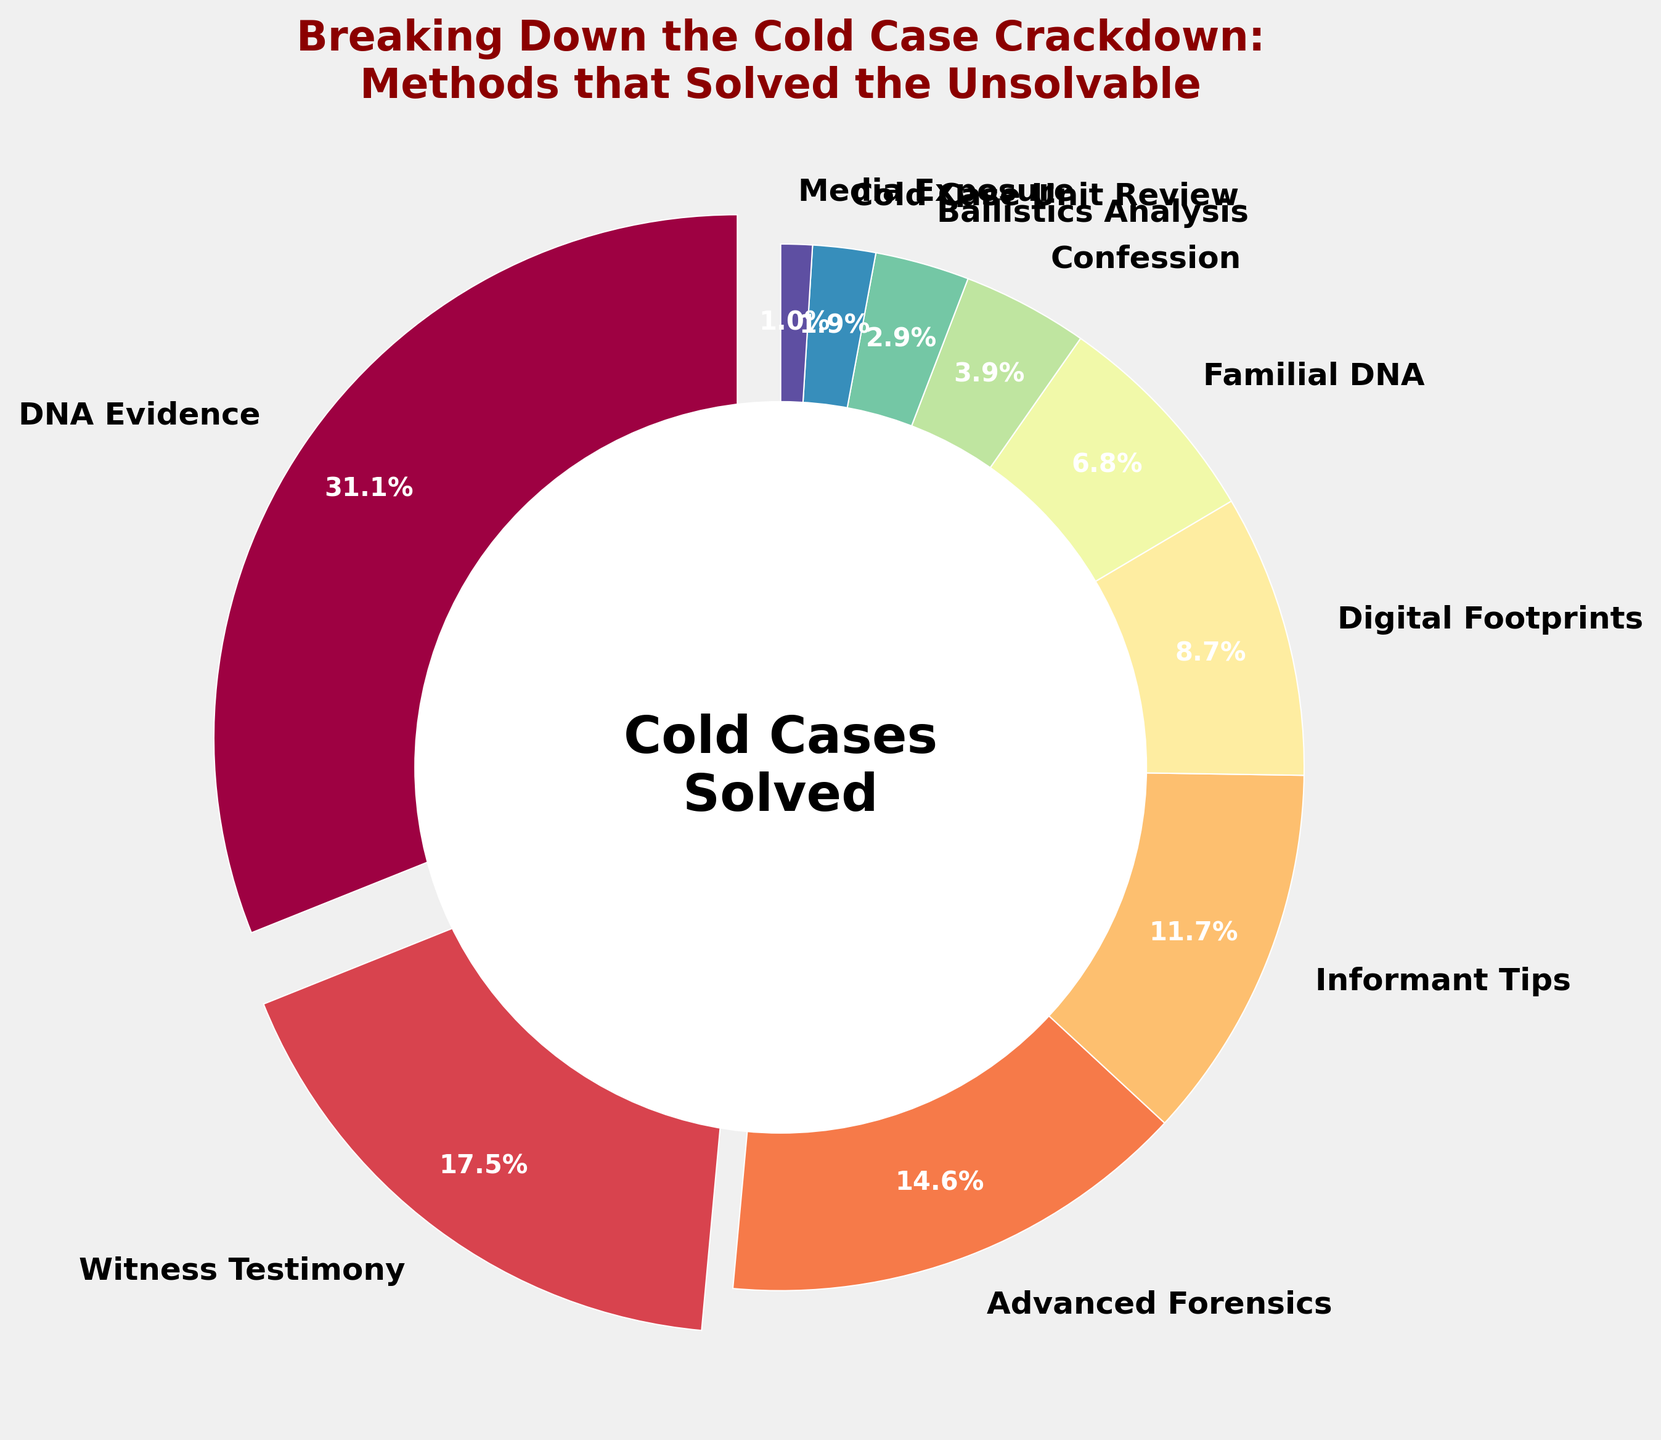What method solved the highest percentage of cold cases? The largest wedge in the pie chart represents DNA Evidence, which is highlighted by the fact that it stands out with a slight “explode” effect and shows 32% on the label.
Answer: DNA Evidence How much more effective is DNA Evidence than Ballistics Analysis in solving cold cases? DNA Evidence solves 32% of cold cases while Ballistics Analysis solves 3%. Subtract the percentage of Ballistics Analysis from DNA Evidence: 32% - 3% = 29%.
Answer: 29% What's the combined percentage of cold cases solved by Informant Tips and Digital Footprints? Informant Tips solve 12% and Digital Footprints solve 9%. Add these two percentages together: 12% + 9% = 21%.
Answer: 21% Which method is visually represented in yellow in the pie chart? The method represented by the yellow color can be identified by visually matching the wedges to their respective colors on the chart. Advanced Forensics is the method in yellow.
Answer: Advanced Forensics Out of the methods that solved fewer than 10% of cold cases, which one has the highest percentage? Identify the methods solving fewer than 10% of cases: Digital Footprints (9%), Familial DNA (7%), Confession (4%), Ballistics Analysis (3%), Cold Case Unit Review (2%), Media Exposure (1%). Among these, Digital Footprints has the highest percentage with 9%.
Answer: Digital Footprints By how much does the percentage of cases solved by Witness Testimony exceed the combined percentages of Ballistics Analysis and Cold Case Unit Review? Witness Testimony solves 18%, Ballistics Analysis 3%, and Cold Case Unit Review 2%. First, find the sum of Ballistics Analysis and Cold Case Unit Review: 3% + 2% = 5%. Then, subtract this sum from Witness Testimony: 18% - 5% = 13%.
Answer: 13% Which method has the smallest wedge in the pie chart? The smallest wedge can be identified visually; it represents Media Exposure, which has the smallest percentage value, 1%.
Answer: Media Exposure What is the difference between the percentages of cases solved by Advanced Forensics and Confession? Advanced Forensics solves 15% and Confession solves 4%. Subtract the percentage of Confession from Advanced Forensics: 15% - 4% = 11%.
Answer: 11% What methods together make up more than half of the cold cases solved? The percentage for each method: DNA Evidence (32%), Witness Testimony (18%), Advanced Forensics (15%), Informant Tips (12%). Add percentages starting with the highest until they exceed half: 32% + 18% + 15% = 65%. These three methods together (DNA Evidence, Witness Testimony, Advanced Forensics) solve more than half.
Answer: DNA Evidence, Witness Testimony, Advanced Forensics Among the methods solving fewer than 5% of cold cases, which one is the second smallest in percentage? Identify methods solving fewer than 5%: Confession (4%), Ballistics Analysis (3%), Cold Case Unit Review (2%), Media Exposure (1%). Sort these to find the second smallest: Media Exposure < Cold Case Unit Review < Ballistics Analysis < Confession. The second smallest is Cold Case Unit Review with 2%.
Answer: Cold Case Unit Review 